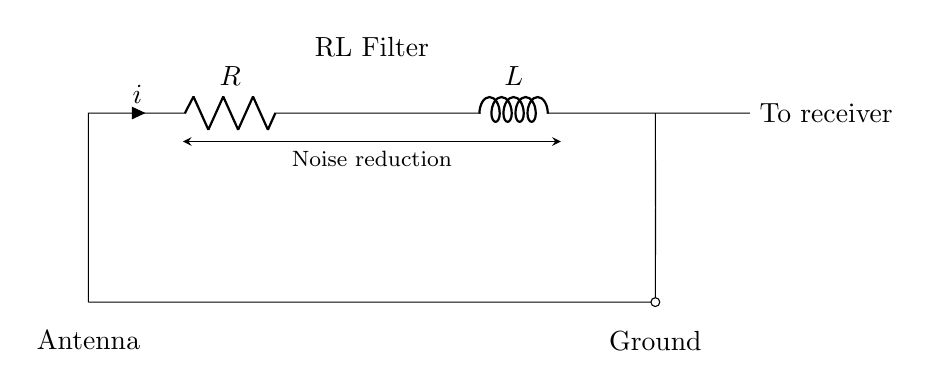What is the component connected to the antenna? The component connected to the antenna is the resistor. It is depicted as R in the diagram and is positioned directly in line with the antenna.
Answer: Resistor What does the label RL Filter indicate? The label RL Filter indicates that this circuit includes both a resistor and an inductor, which are the primary components of this filter designed for reducing noise.
Answer: Resistor and Inductor How many main components are in this circuit? This circuit has two main components: a resistor and an inductor. They are shown in sequence in the diagram, and both are essential for filtering.
Answer: Two What is the purpose of the circuit? The purpose of the circuit, as indicated by the label and the directed line, is to reduce noise in a shortwave radio receiver. This is a functional attribute of an RL filter.
Answer: Noise reduction What is the direction of current flow in this circuit? The direction of current flow in this circuit is from the antenna through the resistor and inductor, heading towards the receiver, as indicated by the arrow labeled 'i'.
Answer: Right How does the inductor affect the circuit's functionality? The inductor introduces inductive reactance, which targets and diminishes high-frequency noise signals, thus improving the quality of the received signal. Inductors are critical in noise filtering.
Answer: Reduces high-frequency noise What is connected to the output side of the inductor? The output side of the inductor is connected to the short taken to the receiver, implying that filtered signals will pass through this point to the receiver.
Answer: To receiver 